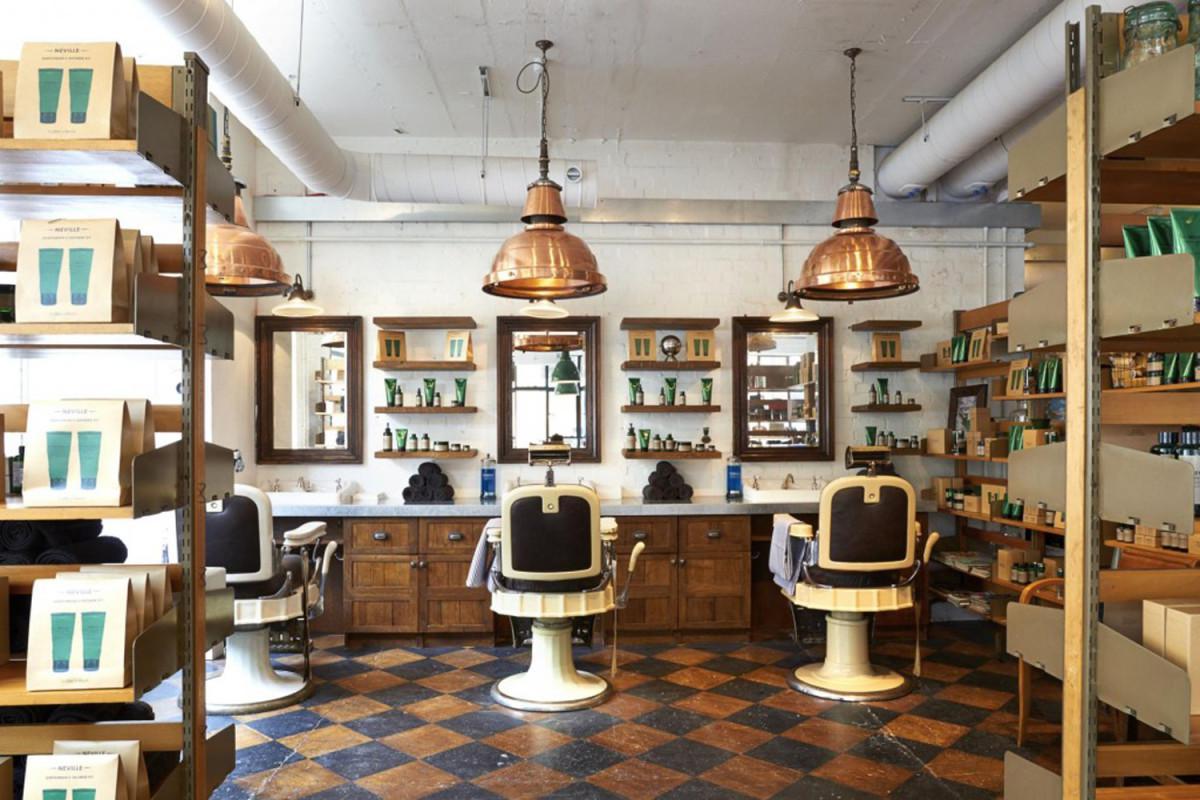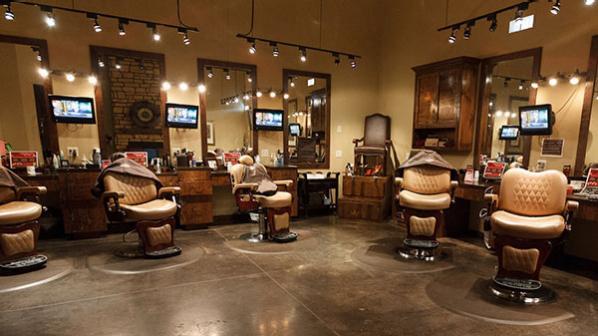The first image is the image on the left, the second image is the image on the right. Examine the images to the left and right. Is the description "There are people in one image but not in the other image." accurate? Answer yes or no. No. The first image is the image on the left, the second image is the image on the right. Assess this claim about the two images: "In one of the images there is a checkered floor and in the other image there is a wooden floor.". Correct or not? Answer yes or no. No. 